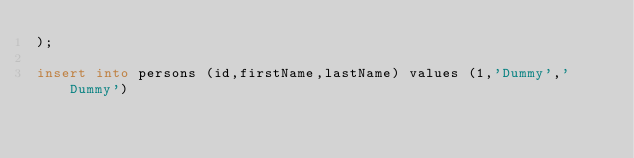Convert code to text. <code><loc_0><loc_0><loc_500><loc_500><_SQL_>);

insert into persons (id,firstName,lastName) values (1,'Dummy','Dummy')
</code> 